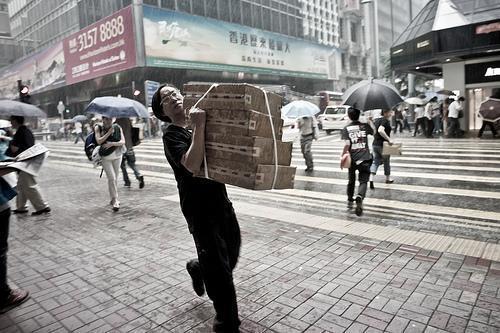How many boxes are visible?
Give a very brief answer. 4. 